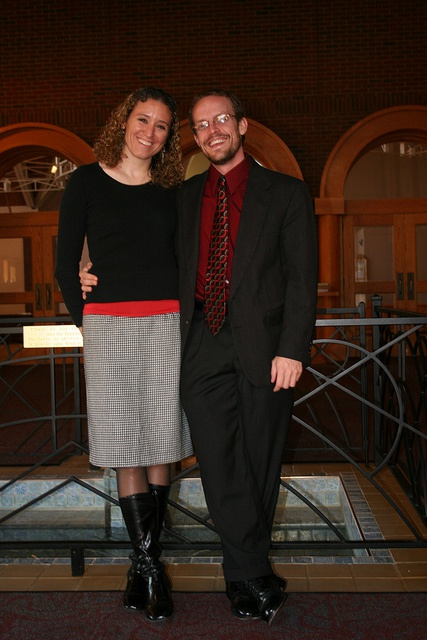Describe the objects in this image and their specific colors. I can see people in black, darkgray, gray, and maroon tones, people in black, maroon, and brown tones, and tie in black, maroon, and brown tones in this image. 